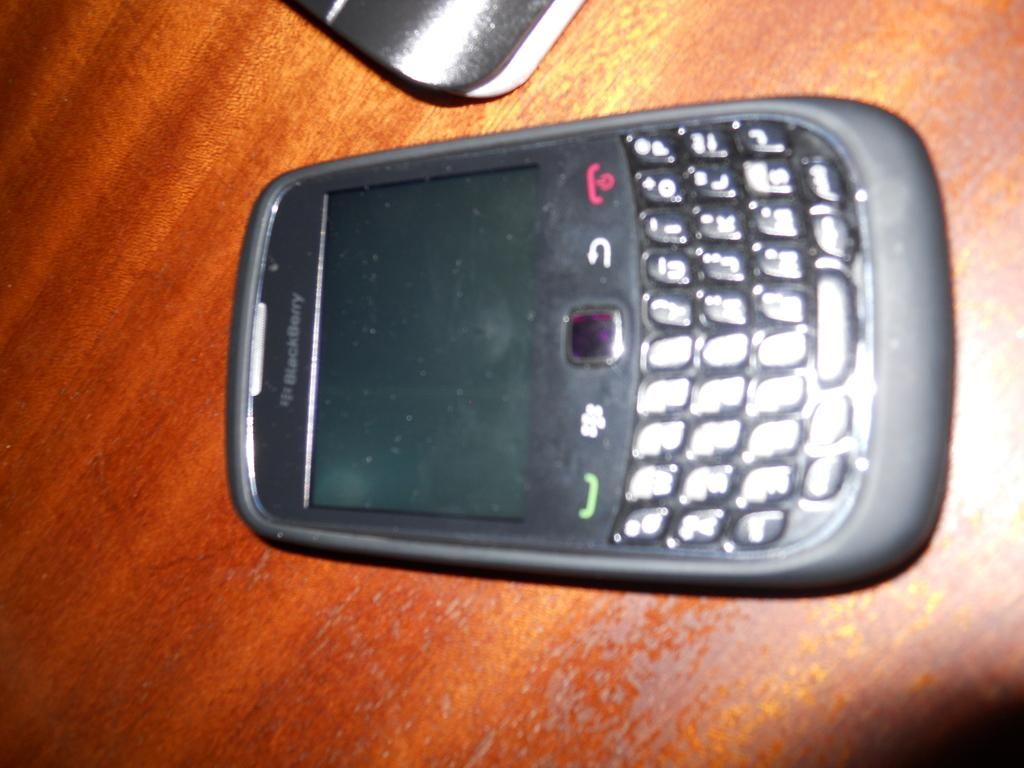<image>
Share a concise interpretation of the image provided. A Blackberry face up and turned off on a wood table. 